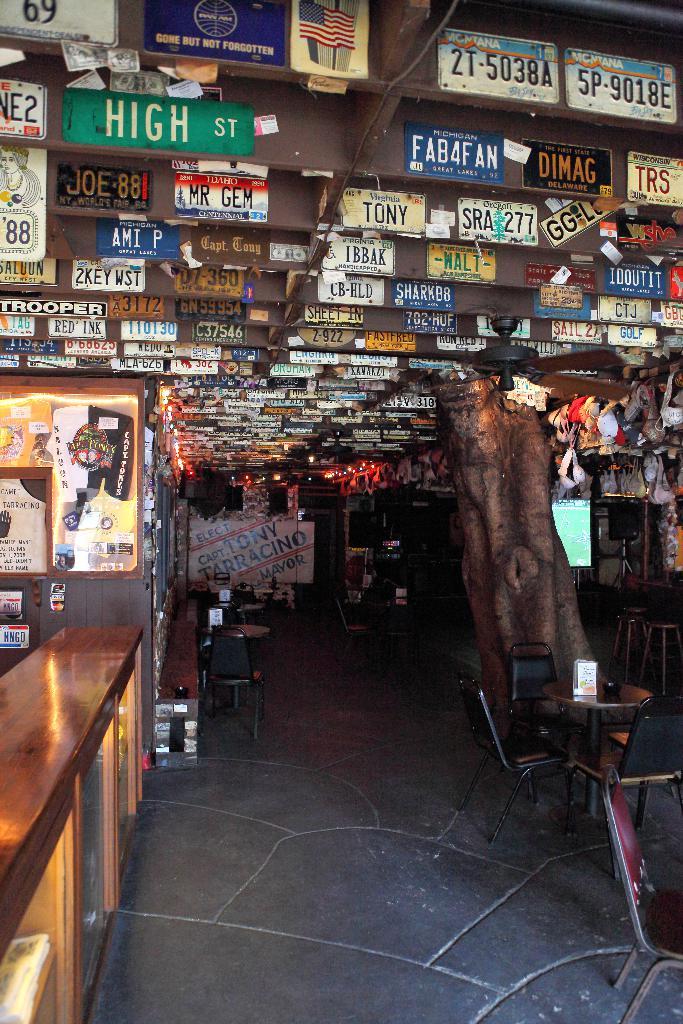What street name can you see?
Ensure brevity in your answer.  High st. What is the street name on the sign in green?
Give a very brief answer. High. 